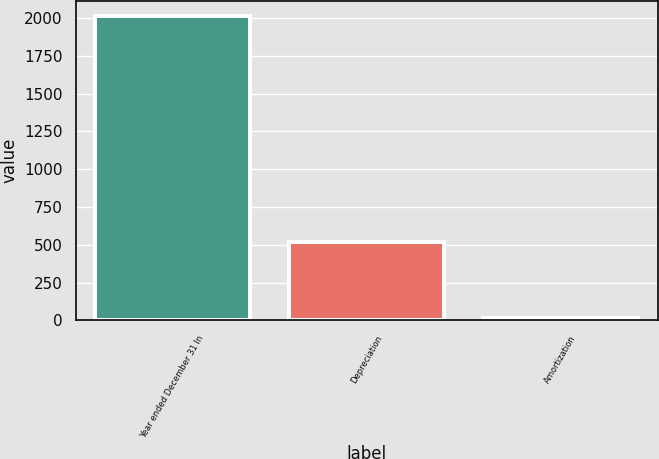Convert chart. <chart><loc_0><loc_0><loc_500><loc_500><bar_chart><fcel>Year ended December 31 In<fcel>Depreciation<fcel>Amortization<nl><fcel>2012<fcel>521<fcel>19<nl></chart> 